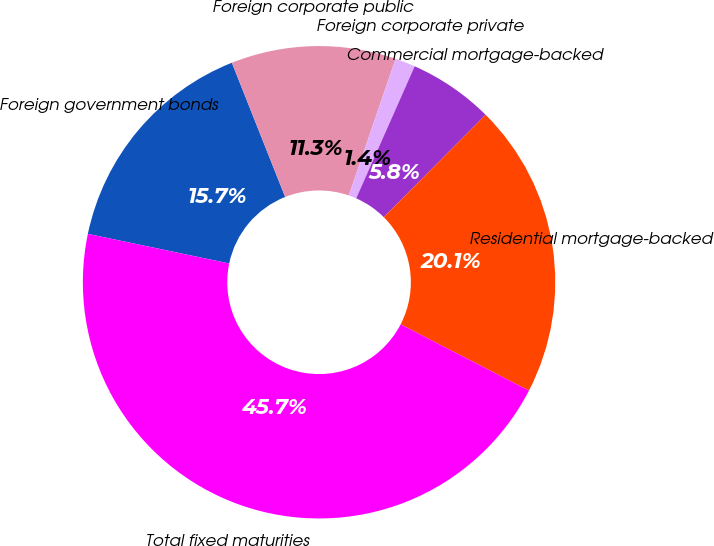Convert chart to OTSL. <chart><loc_0><loc_0><loc_500><loc_500><pie_chart><fcel>Foreign government bonds<fcel>Foreign corporate public<fcel>Foreign corporate private<fcel>Commercial mortgage-backed<fcel>Residential mortgage-backed<fcel>Total fixed maturities<nl><fcel>15.7%<fcel>11.27%<fcel>1.38%<fcel>5.82%<fcel>20.13%<fcel>45.7%<nl></chart> 